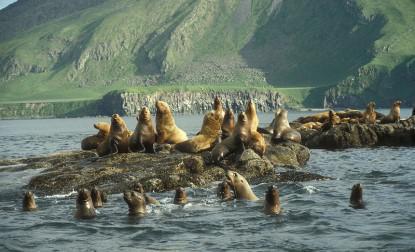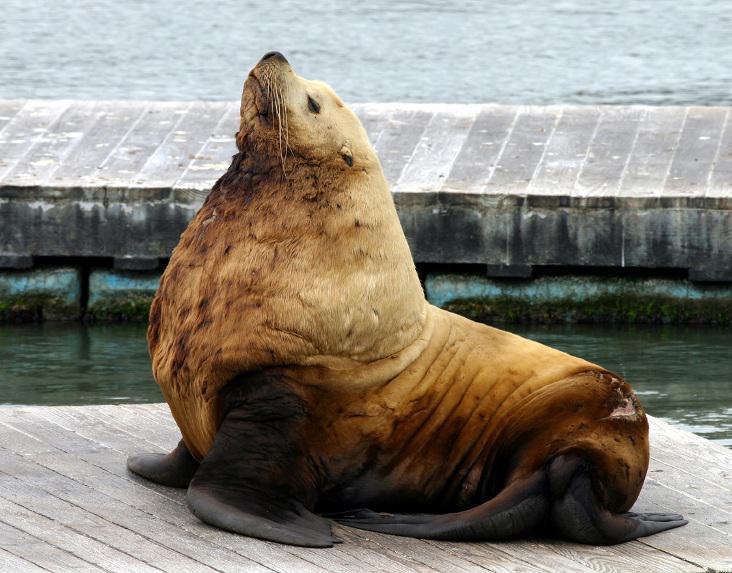The first image is the image on the left, the second image is the image on the right. Analyze the images presented: Is the assertion "There is one animal by the water in one of the images." valid? Answer yes or no. Yes. 